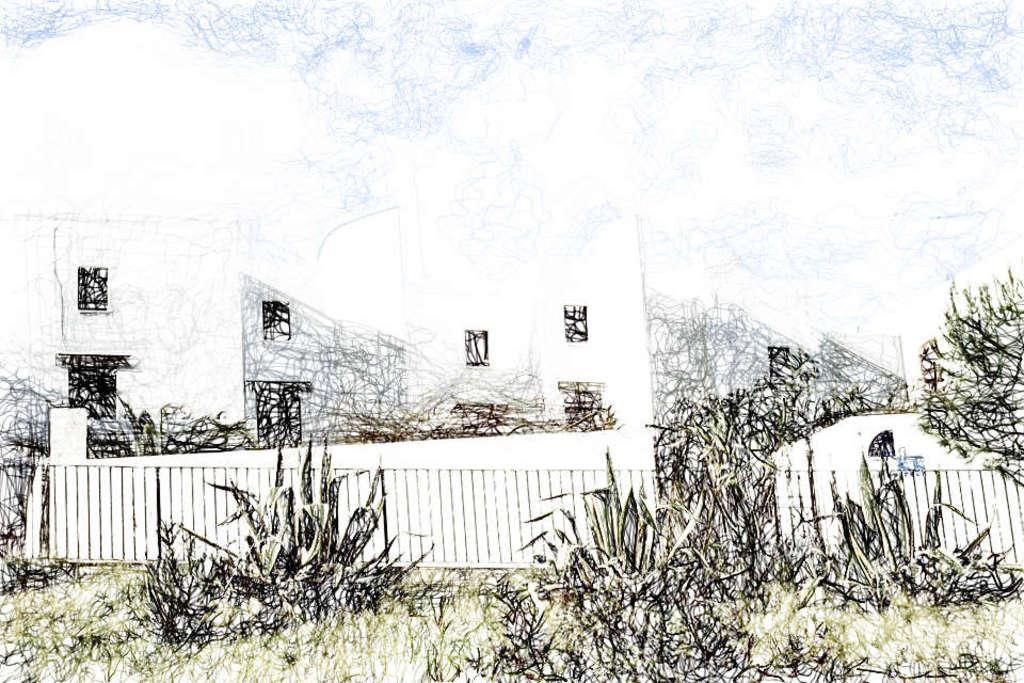How would you summarize this image in a sentence or two? This is a sketch and here we can see a building and there are trees, and plants and a fence. 